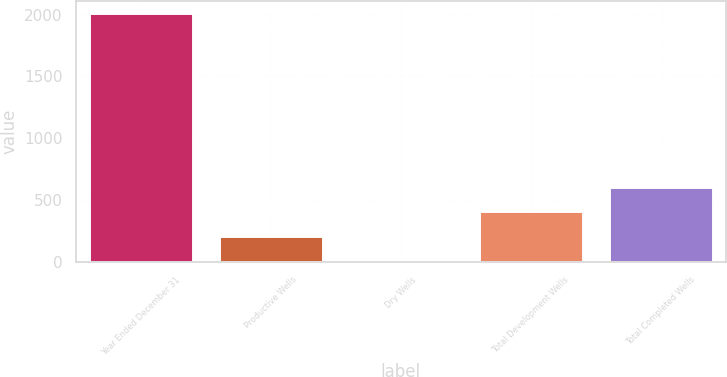Convert chart. <chart><loc_0><loc_0><loc_500><loc_500><bar_chart><fcel>Year Ended December 31<fcel>Productive Wells<fcel>Dry Wells<fcel>Total Development Wells<fcel>Total Completed Wells<nl><fcel>2012<fcel>208.4<fcel>8<fcel>408.8<fcel>609.2<nl></chart> 